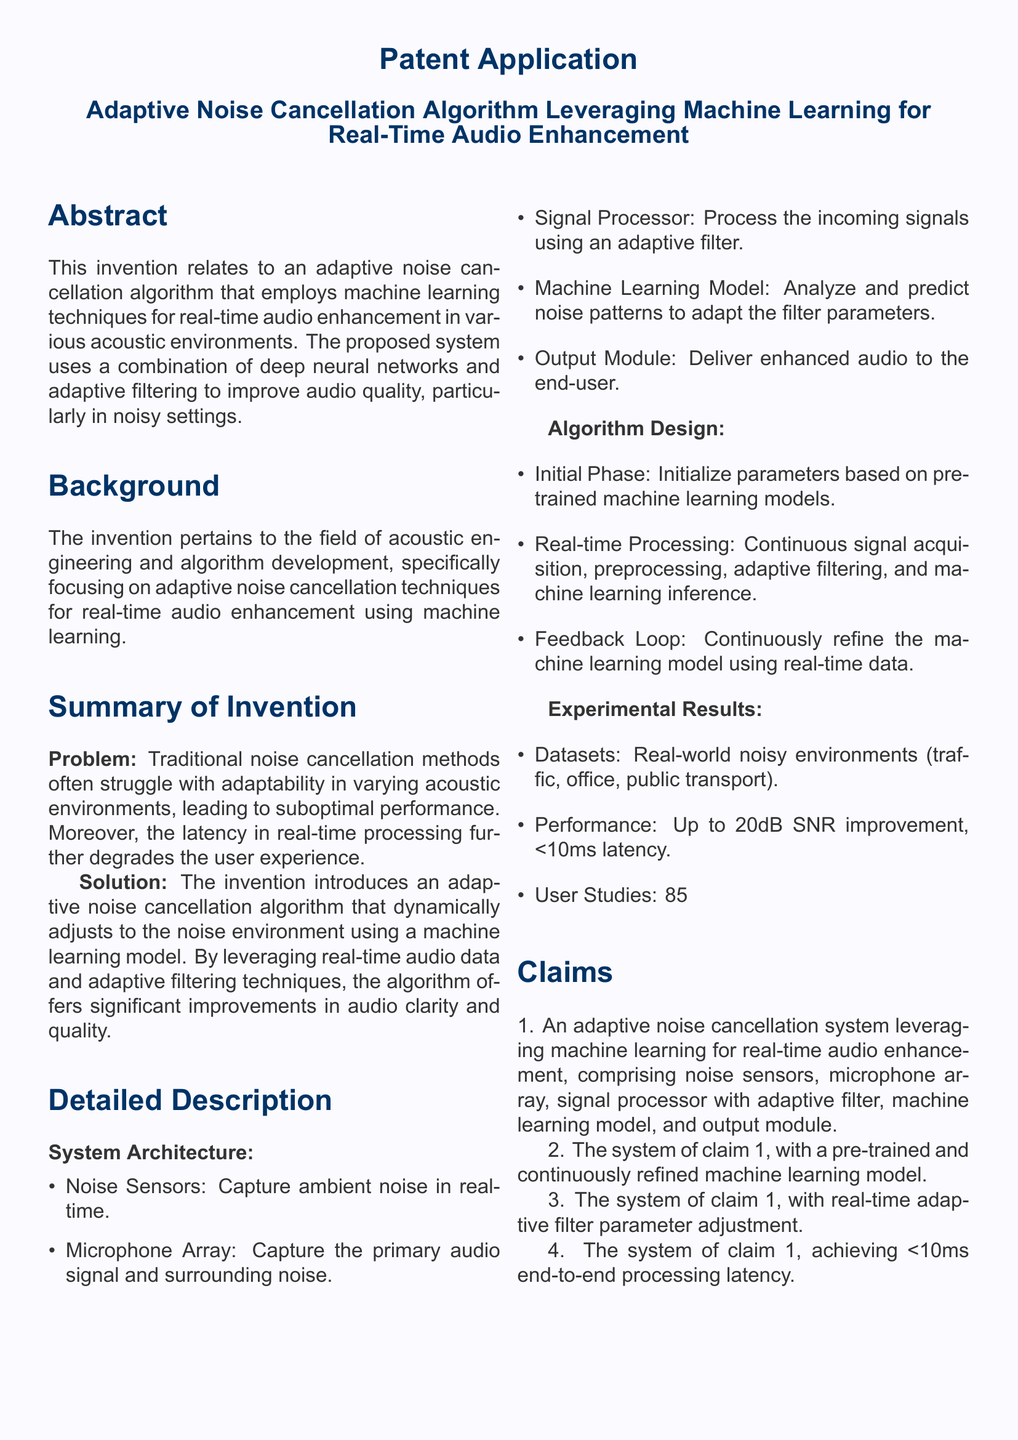What is the title of the patent application? The title of the patent application is stated in the document header, indicating the invention's focus.
Answer: Adaptive Noise Cancellation Algorithm Leveraging Machine Learning for Real-Time Audio Enhancement What is the primary improvement over traditional methods? The problem section highlights that traditional noise cancellation methods struggle with adaptability and real-time processing latency.
Answer: Adaptability What is the expected latency of the system? The claims outline specific performance criteria, including latency.
Answer: <10ms How much SNR improvement is reported in experimental results? The experimental results section explicitly mentions the performance improvement in terms of SNR.
Answer: Up to 20dB What are the components of the system architecture? The detailed description enumerates the components required for the proposed system, forming its architecture.
Answer: Noise Sensors, Microphone Array, Signal Processor, Machine Learning Model, Output Module What percentage of participants noted substantial improvement? User studies provide quantifiable feedback regarding user experience with the system.
Answer: 85% What kind of environments were used for testing? The experimental results list the types of environments that were part of the datasets collected for testing performance.
Answer: Real-world noisy environments (traffic, office, public transport) What type of machine learning model is used? The system works with a machine learning model that is both pre-trained and continuously refined throughout usage.
Answer: Pre-trained and continuously refined What does the feedback loop do? The detailed description indicates the feedback loop's purpose within the algorithm, which contributes to its adaptability.
Answer: Continuously refine the machine learning model using real-time data 